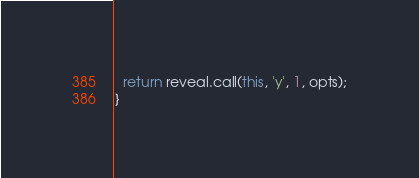Convert code to text. <code><loc_0><loc_0><loc_500><loc_500><_JavaScript_>  return reveal.call(this, 'y', 1, opts);
}
</code> 